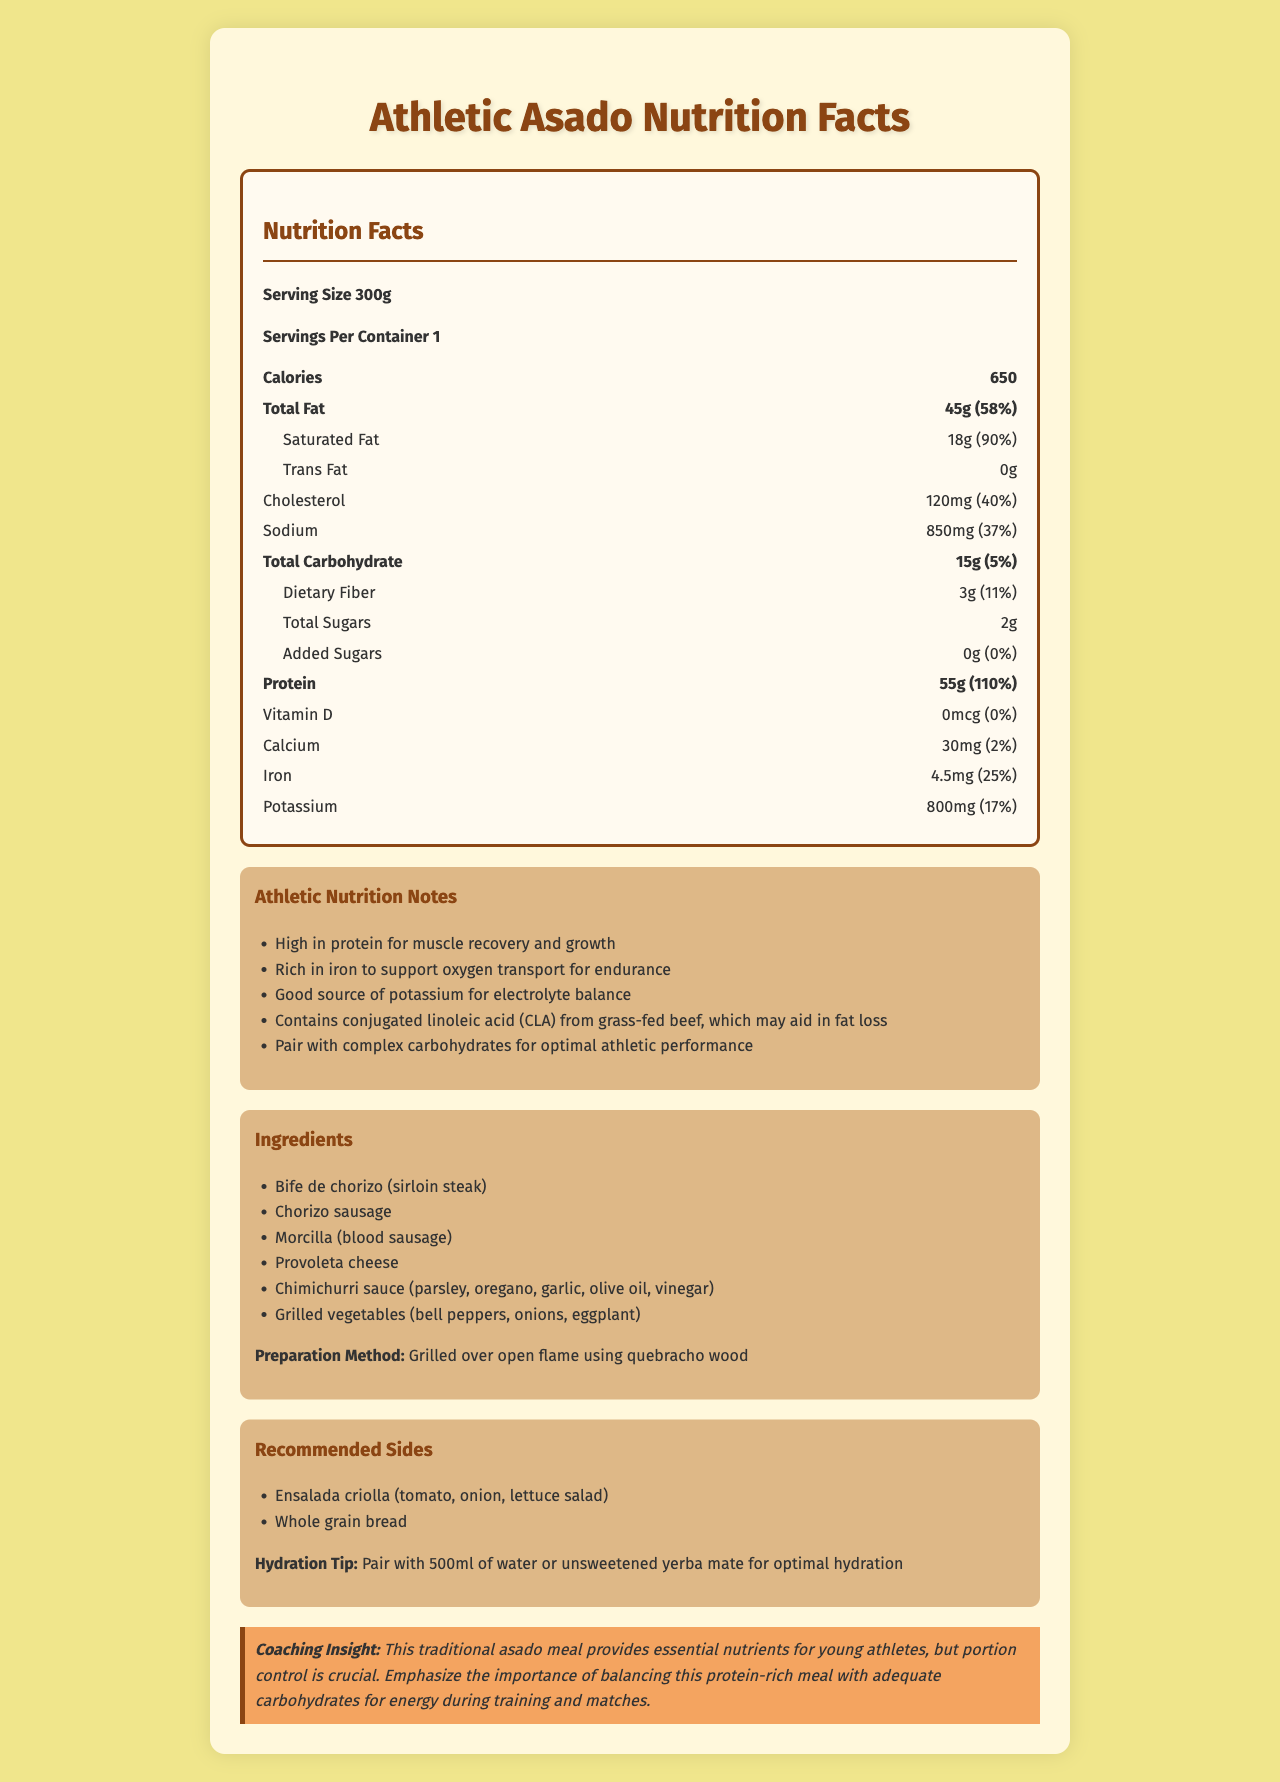what is the serving size? The serving size is listed at the beginning of the Nutrition Facts section as "Serving Size 300g".
Answer: 300g how many grams of total fat are in one serving? The total amount of fat for one serving is listed as 45g in the Nutrition Facts section.
Answer: 45g how much protein is in one serving? The protein amount per serving is specified as 55g in the Nutrition Facts section.
Answer: 55g what is the main ingredient in this asado meal? The main ingredient is listed first in the Ingredients section: "Bife de chorizo (sirloin steak)".
Answer: Bife de chorizo (sirloin steak) what sides are recommended with this meal? The Recommended Sides section lists "Ensalada criolla (tomato, onion, lettuce salad)" and "Whole grain bread".
Answer: Ensalada criolla (tomato, onion, lettuce salad), Whole grain bread how much cholesterol is in one serving? The amount of cholesterol per serving is specified as 120mg in the Nutrition Facts section.
Answer: 120mg what percentage of your daily iron requirement does one serving contain? The Daily Value percentage for iron is listed as 25% in the Nutrition Facts section.
Answer: 25% how many calories are in one serving? The total calorie count per serving is 650, as listed in the Nutrition Facts section.
Answer: 650 calories what type of fat is not present in this meal? The Nutrition Facts section indicates that there are 0g of trans fat.
Answer: Trans Fat how much saturated fat is in one serving of this meal? The Nutrition Facts section lists saturated fat content as 18g.
Answer: 18g which of the following vitamins is not present in this meal? A. Vitamin C B. Vitamin D C. Vitamin A D. Vitamin B12 The Nutrition Facts section shows 0% daily value for Vitamin D, indicating it is not present in the meal.
Answer: B. Vitamin D what percentage of your daily sodium intake does one serving of this meal provide? A. 25% B. 37% C. 50% D. 75% The Daily Value percentage for sodium is listed as 37% in the Nutrition Facts section.
Answer: B. 37% is there any added sugar in this meal? The Nutrition Facts section states that there are 0g of added sugars.
Answer: No are there any hydration tips provided in the document? The document mentions a hydration tip which recommends pairing with 500ml of water or unsweetened yerba mate for optimal hydration.
Answer: Yes summarize the main purpose of this document. The document contains a detailed breakdown of nutritional values, highlights key nutrients beneficial for athletes, lists ingredients, preparation methods, recommended sides, and provides a coaching insight to guide proper nutritional balance for young athletes.
Answer: The main purpose of the document is to provide detailed nutritional information about a traditional Argentine asado meal that has been adapted for athletic nutrition. It highlights the beneficial nutrients for athletes, a list of ingredients, preparation method, recommended sides, and a coaching insight on balancing protein with adequate carbohydrates for optimal performance. what is the source of conjugated linoleic acid (CLA) in this meal? The Athletic Nutrition Notes section states that CLA comes from grass-fed beef in the meal.
Answer: Grass-fed beef how should this meal be prepared? The preparation method section specifies that the meal should be grilled over an open flame using quebracho wood.
Answer: Grilled over open flame using quebracho wood what is the total carbohydrate content in one serving? The Nutrition Facts section lists the total carbohydrate content as 15g per serving.
Answer: 15g what is the daily value percentage of dietary fiber for one serving? The Daily Value percentage for dietary fiber is listed as 11% in the Nutrition Facts section.
Answer: 11% does this document mention the calorie content of chimichurri sauce specifically? The document provides the overall nutritional information for the entire asado meal but does not specify the calorie content of individual components like chimichurri sauce.
Answer: Cannot be determined 